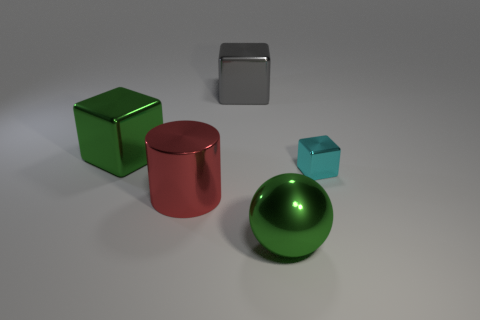Subtract all big gray metal blocks. How many blocks are left? 2 Subtract all green cubes. How many cubes are left? 2 Subtract all spheres. How many objects are left? 4 Add 2 gray shiny balls. How many objects exist? 7 Subtract 0 gray cylinders. How many objects are left? 5 Subtract all blue blocks. Subtract all brown cylinders. How many blocks are left? 3 Subtract all green spheres. How many blue cylinders are left? 0 Subtract all red things. Subtract all small red matte things. How many objects are left? 4 Add 2 gray cubes. How many gray cubes are left? 3 Add 1 large metallic balls. How many large metallic balls exist? 2 